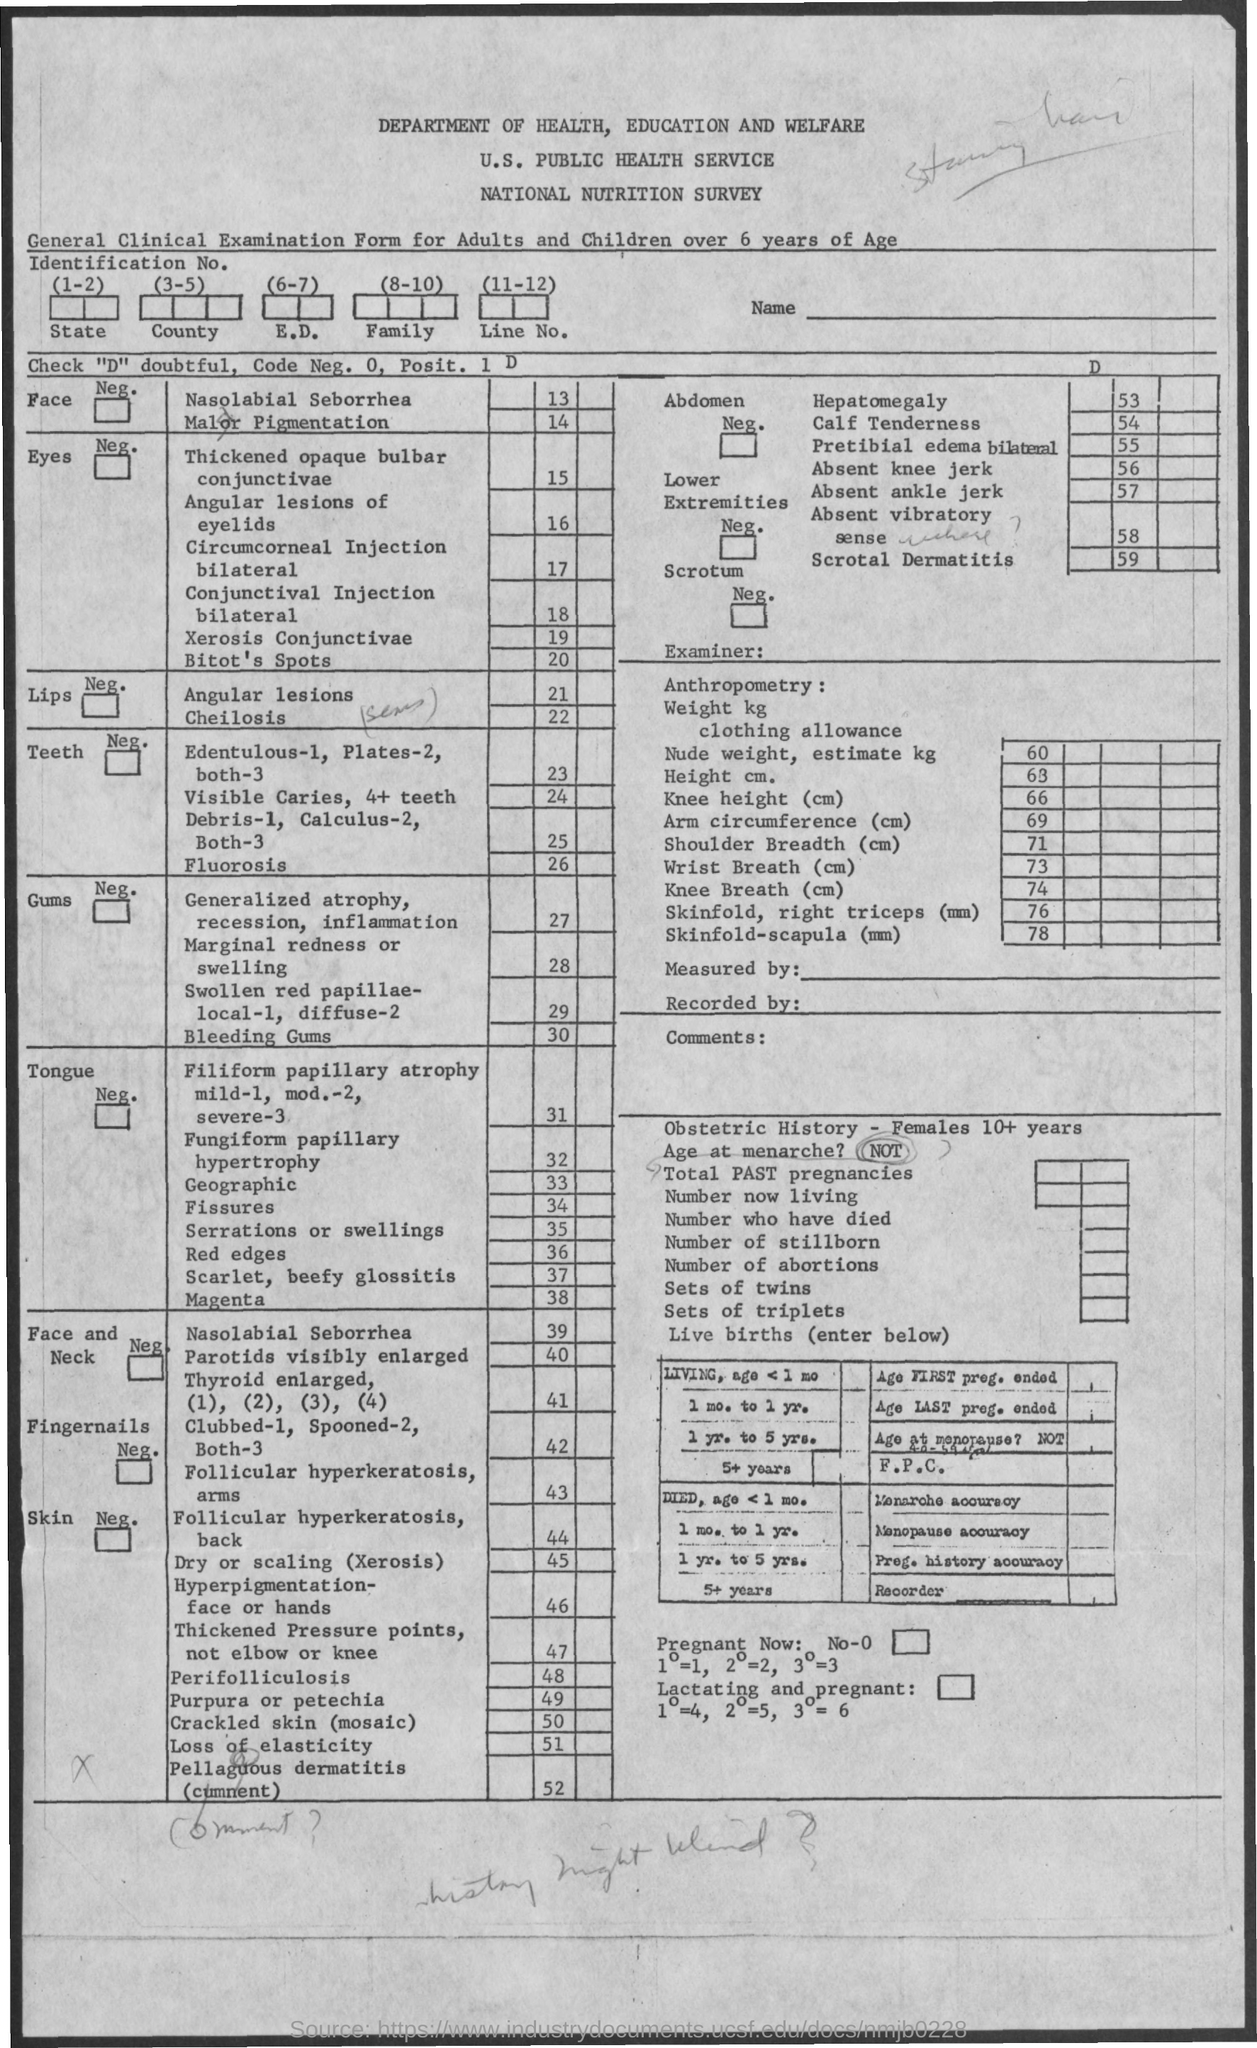What is the name of the survey ?
Keep it short and to the point. National nutrition survey. What is the department name mentioned ?
Make the answer very short. Department of health, education and welfare. 